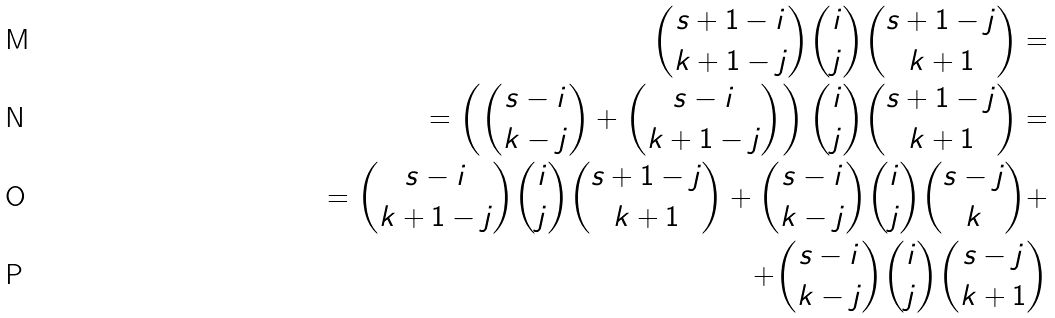<formula> <loc_0><loc_0><loc_500><loc_500>\binom { s + 1 - i } { k + 1 - j } \binom { i } { j } \binom { s + 1 - j } { k + 1 } = \\ = \left ( \binom { s - i } { k - j } + \binom { s - i } { k + 1 - j } \right ) \binom { i } { j } \binom { s + 1 - j } { k + 1 } = \\ = \binom { s - i } { k + 1 - j } \binom { i } { j } \binom { s + 1 - j } { k + 1 } + \binom { s - i } { k - j } \binom { i } { j } \binom { s - j } { k } + \\ + \binom { s - i } { k - j } \binom { i } { j } \binom { s - j } { k + 1 }</formula> 